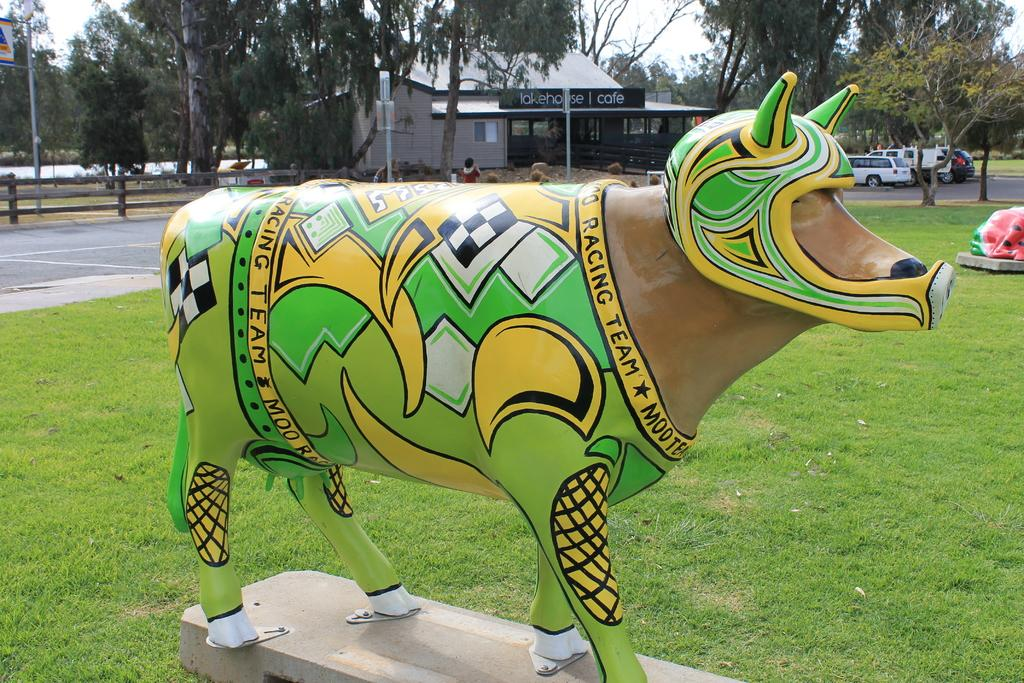What is located in the foreground of the image? There is a toy in the foreground of the image. What can be seen in the background of the image? There are cars, a house, a fence, and trees in the background of the image. What type of vegetation is present at the bottom of the image? There is grass at the bottom of the image. What type of lumber is being used to construct the fence in the image? There is no information about the type of lumber used to construct the fence in the image. Can you identify the actor playing the role of the toy in the image? The image does not depict a toy as an actor; it is a static toy in the foreground. 